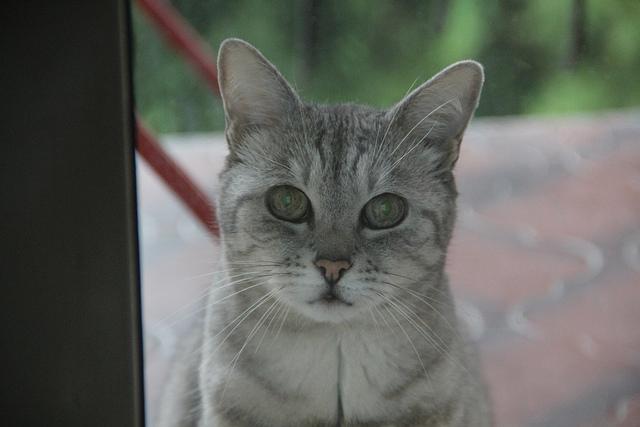Is this animal vegetarian?
Short answer required. No. Is this a dog?
Quick response, please. No. What is the cat doing?
Write a very short answer. Staring. What is the cat looking at?
Write a very short answer. Camera. What is the cat sitting on?
Be succinct. Ground. What color eyes does this cat have?
Give a very brief answer. Green. Is that an outside cat?
Short answer required. Yes. Would you expect this animal to play with yarn?
Keep it brief. Yes. Is the cat eyes opened or closed?
Quick response, please. Open. What color are the insides of the cat's ears?
Keep it brief. White. 